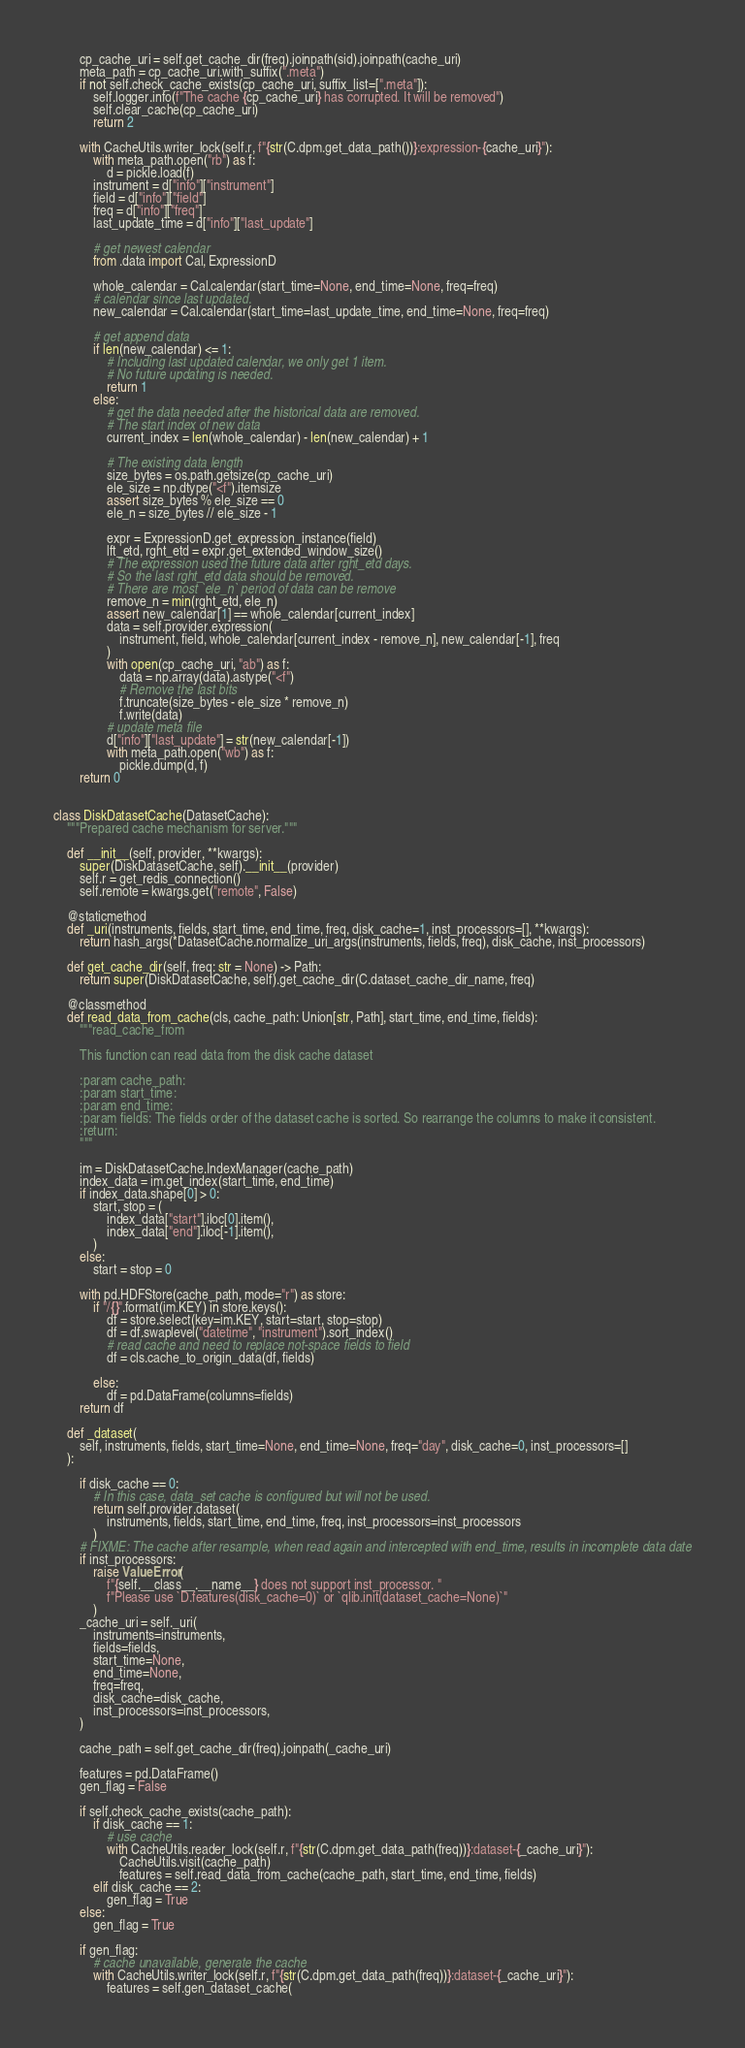<code> <loc_0><loc_0><loc_500><loc_500><_Python_>        cp_cache_uri = self.get_cache_dir(freq).joinpath(sid).joinpath(cache_uri)
        meta_path = cp_cache_uri.with_suffix(".meta")
        if not self.check_cache_exists(cp_cache_uri, suffix_list=[".meta"]):
            self.logger.info(f"The cache {cp_cache_uri} has corrupted. It will be removed")
            self.clear_cache(cp_cache_uri)
            return 2

        with CacheUtils.writer_lock(self.r, f"{str(C.dpm.get_data_path())}:expression-{cache_uri}"):
            with meta_path.open("rb") as f:
                d = pickle.load(f)
            instrument = d["info"]["instrument"]
            field = d["info"]["field"]
            freq = d["info"]["freq"]
            last_update_time = d["info"]["last_update"]

            # get newest calendar
            from .data import Cal, ExpressionD

            whole_calendar = Cal.calendar(start_time=None, end_time=None, freq=freq)
            # calendar since last updated.
            new_calendar = Cal.calendar(start_time=last_update_time, end_time=None, freq=freq)

            # get append data
            if len(new_calendar) <= 1:
                # Including last updated calendar, we only get 1 item.
                # No future updating is needed.
                return 1
            else:
                # get the data needed after the historical data are removed.
                # The start index of new data
                current_index = len(whole_calendar) - len(new_calendar) + 1

                # The existing data length
                size_bytes = os.path.getsize(cp_cache_uri)
                ele_size = np.dtype("<f").itemsize
                assert size_bytes % ele_size == 0
                ele_n = size_bytes // ele_size - 1

                expr = ExpressionD.get_expression_instance(field)
                lft_etd, rght_etd = expr.get_extended_window_size()
                # The expression used the future data after rght_etd days.
                # So the last rght_etd data should be removed.
                # There are most `ele_n` period of data can be remove
                remove_n = min(rght_etd, ele_n)
                assert new_calendar[1] == whole_calendar[current_index]
                data = self.provider.expression(
                    instrument, field, whole_calendar[current_index - remove_n], new_calendar[-1], freq
                )
                with open(cp_cache_uri, "ab") as f:
                    data = np.array(data).astype("<f")
                    # Remove the last bits
                    f.truncate(size_bytes - ele_size * remove_n)
                    f.write(data)
                # update meta file
                d["info"]["last_update"] = str(new_calendar[-1])
                with meta_path.open("wb") as f:
                    pickle.dump(d, f)
        return 0


class DiskDatasetCache(DatasetCache):
    """Prepared cache mechanism for server."""

    def __init__(self, provider, **kwargs):
        super(DiskDatasetCache, self).__init__(provider)
        self.r = get_redis_connection()
        self.remote = kwargs.get("remote", False)

    @staticmethod
    def _uri(instruments, fields, start_time, end_time, freq, disk_cache=1, inst_processors=[], **kwargs):
        return hash_args(*DatasetCache.normalize_uri_args(instruments, fields, freq), disk_cache, inst_processors)

    def get_cache_dir(self, freq: str = None) -> Path:
        return super(DiskDatasetCache, self).get_cache_dir(C.dataset_cache_dir_name, freq)

    @classmethod
    def read_data_from_cache(cls, cache_path: Union[str, Path], start_time, end_time, fields):
        """read_cache_from

        This function can read data from the disk cache dataset

        :param cache_path:
        :param start_time:
        :param end_time:
        :param fields: The fields order of the dataset cache is sorted. So rearrange the columns to make it consistent.
        :return:
        """

        im = DiskDatasetCache.IndexManager(cache_path)
        index_data = im.get_index(start_time, end_time)
        if index_data.shape[0] > 0:
            start, stop = (
                index_data["start"].iloc[0].item(),
                index_data["end"].iloc[-1].item(),
            )
        else:
            start = stop = 0

        with pd.HDFStore(cache_path, mode="r") as store:
            if "/{}".format(im.KEY) in store.keys():
                df = store.select(key=im.KEY, start=start, stop=stop)
                df = df.swaplevel("datetime", "instrument").sort_index()
                # read cache and need to replace not-space fields to field
                df = cls.cache_to_origin_data(df, fields)

            else:
                df = pd.DataFrame(columns=fields)
        return df

    def _dataset(
        self, instruments, fields, start_time=None, end_time=None, freq="day", disk_cache=0, inst_processors=[]
    ):

        if disk_cache == 0:
            # In this case, data_set cache is configured but will not be used.
            return self.provider.dataset(
                instruments, fields, start_time, end_time, freq, inst_processors=inst_processors
            )
        # FIXME: The cache after resample, when read again and intercepted with end_time, results in incomplete data date
        if inst_processors:
            raise ValueError(
                f"{self.__class__.__name__} does not support inst_processor. "
                f"Please use `D.features(disk_cache=0)` or `qlib.init(dataset_cache=None)`"
            )
        _cache_uri = self._uri(
            instruments=instruments,
            fields=fields,
            start_time=None,
            end_time=None,
            freq=freq,
            disk_cache=disk_cache,
            inst_processors=inst_processors,
        )

        cache_path = self.get_cache_dir(freq).joinpath(_cache_uri)

        features = pd.DataFrame()
        gen_flag = False

        if self.check_cache_exists(cache_path):
            if disk_cache == 1:
                # use cache
                with CacheUtils.reader_lock(self.r, f"{str(C.dpm.get_data_path(freq))}:dataset-{_cache_uri}"):
                    CacheUtils.visit(cache_path)
                    features = self.read_data_from_cache(cache_path, start_time, end_time, fields)
            elif disk_cache == 2:
                gen_flag = True
        else:
            gen_flag = True

        if gen_flag:
            # cache unavailable, generate the cache
            with CacheUtils.writer_lock(self.r, f"{str(C.dpm.get_data_path(freq))}:dataset-{_cache_uri}"):
                features = self.gen_dataset_cache(</code> 